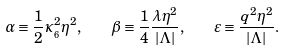<formula> <loc_0><loc_0><loc_500><loc_500>\alpha \equiv \frac { 1 } { 2 } \kappa _ { _ { 6 } } ^ { 2 } \eta ^ { 2 } , \quad \beta \equiv \frac { 1 } { 4 } \frac { \lambda \eta ^ { 2 } } { | \Lambda | } , \quad \varepsilon \equiv \frac { q ^ { 2 } \eta ^ { 2 } } { | \Lambda | } .</formula> 